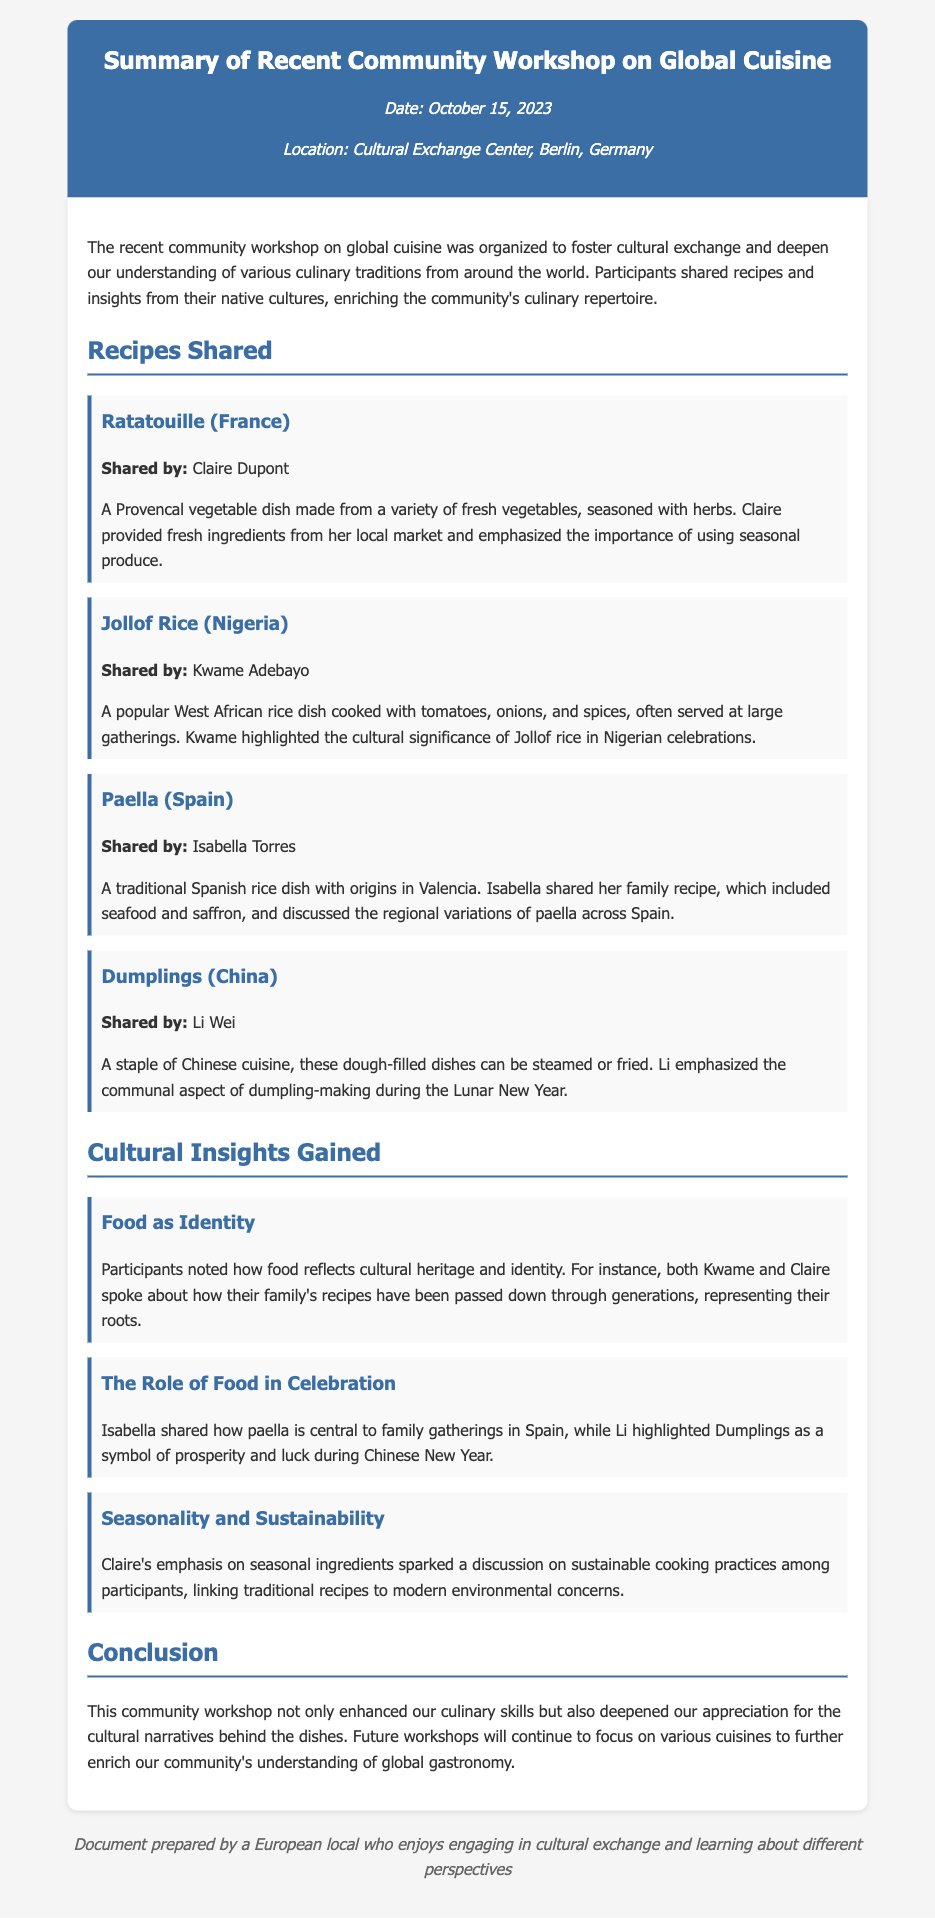What is the date of the workshop? The date of the workshop is mentioned in the document as October 15, 2023.
Answer: October 15, 2023 Who shared the recipe for Ratatouille? The document specifies that Claire Dupont shared the recipe for Ratatouille.
Answer: Claire Dupont What is a key ingredient in Jollof Rice? The document highlights that tomatoes are a key ingredient cooked with rice in Jollof Rice.
Answer: Tomatoes What does Li Wei emphasize about dumplings? The document states that Li emphasized the communal aspect of dumpling-making during the Lunar New Year.
Answer: Communal aspect Which dish is highlighted as a symbol of prosperity in Chinese culture? The document mentions that Dumplings are highlighted as a symbol of prosperity during Chinese New Year.
Answer: Dumplings What cultural significance does Jollof Rice have? The document explains that Jollof rice holds cultural significance in Nigerian celebrations, particularly at large gatherings.
Answer: Nigerian celebrations Which cuisine emphasizes seasonal ingredients? The document indicates that Claire emphasized the importance of using seasonal produce in her recipe.
Answer: French How does the document categorize the shared recipes? The document categorizes the shared recipes under the heading "Recipes Shared," organizing them by the country of origin and the person who shared them.
Answer: Recipes Shared What is the overall purpose of the workshop according to the document? The document states that the purpose of the workshop was to foster cultural exchange and deepen understanding of various culinary traditions.
Answer: Foster cultural exchange 